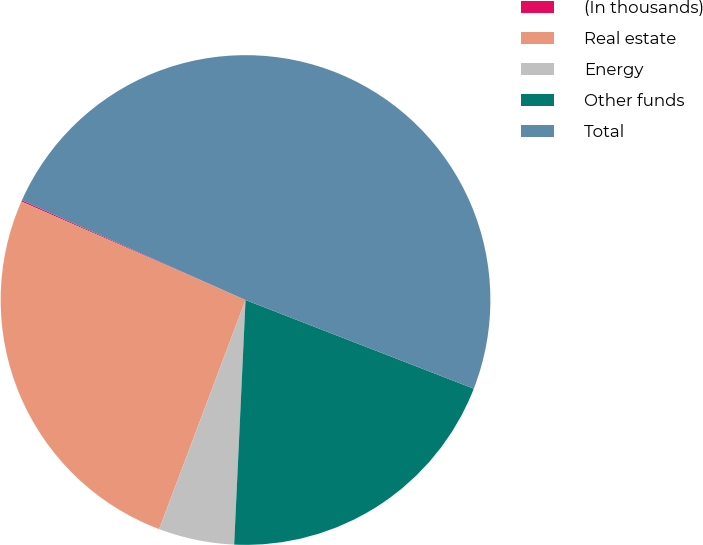Convert chart to OTSL. <chart><loc_0><loc_0><loc_500><loc_500><pie_chart><fcel>(In thousands)<fcel>Real estate<fcel>Energy<fcel>Other funds<fcel>Total<nl><fcel>0.09%<fcel>25.85%<fcel>5.0%<fcel>19.84%<fcel>49.22%<nl></chart> 